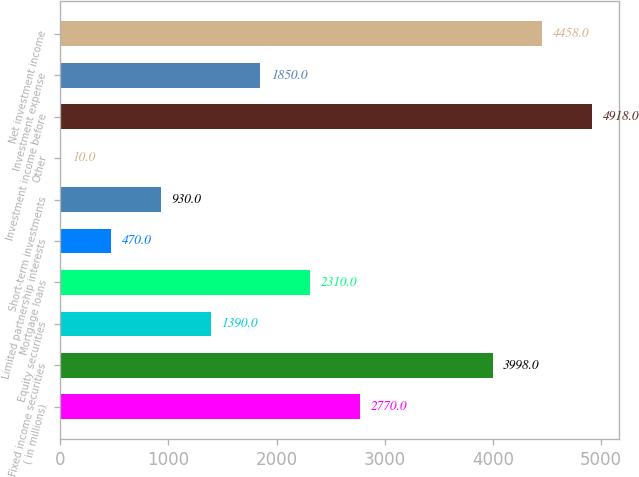<chart> <loc_0><loc_0><loc_500><loc_500><bar_chart><fcel>( in millions)<fcel>Fixed income securities<fcel>Equity securities<fcel>Mortgage loans<fcel>Limited partnership interests<fcel>Short-term investments<fcel>Other<fcel>Investment income before<fcel>Investment expense<fcel>Net investment income<nl><fcel>2770<fcel>3998<fcel>1390<fcel>2310<fcel>470<fcel>930<fcel>10<fcel>4918<fcel>1850<fcel>4458<nl></chart> 